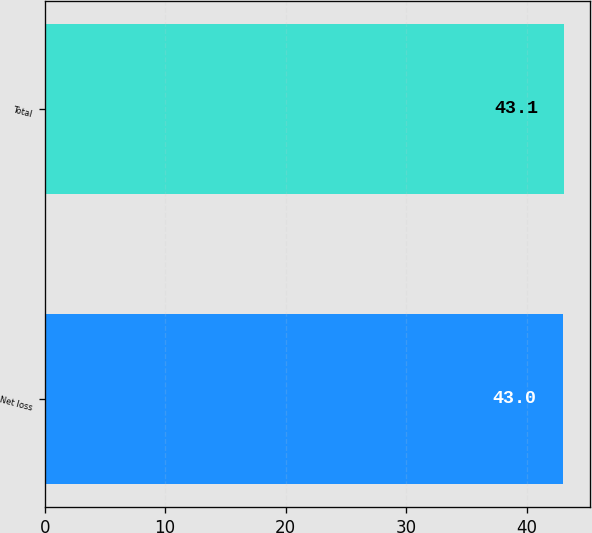Convert chart to OTSL. <chart><loc_0><loc_0><loc_500><loc_500><bar_chart><fcel>Net loss<fcel>Total<nl><fcel>43<fcel>43.1<nl></chart> 